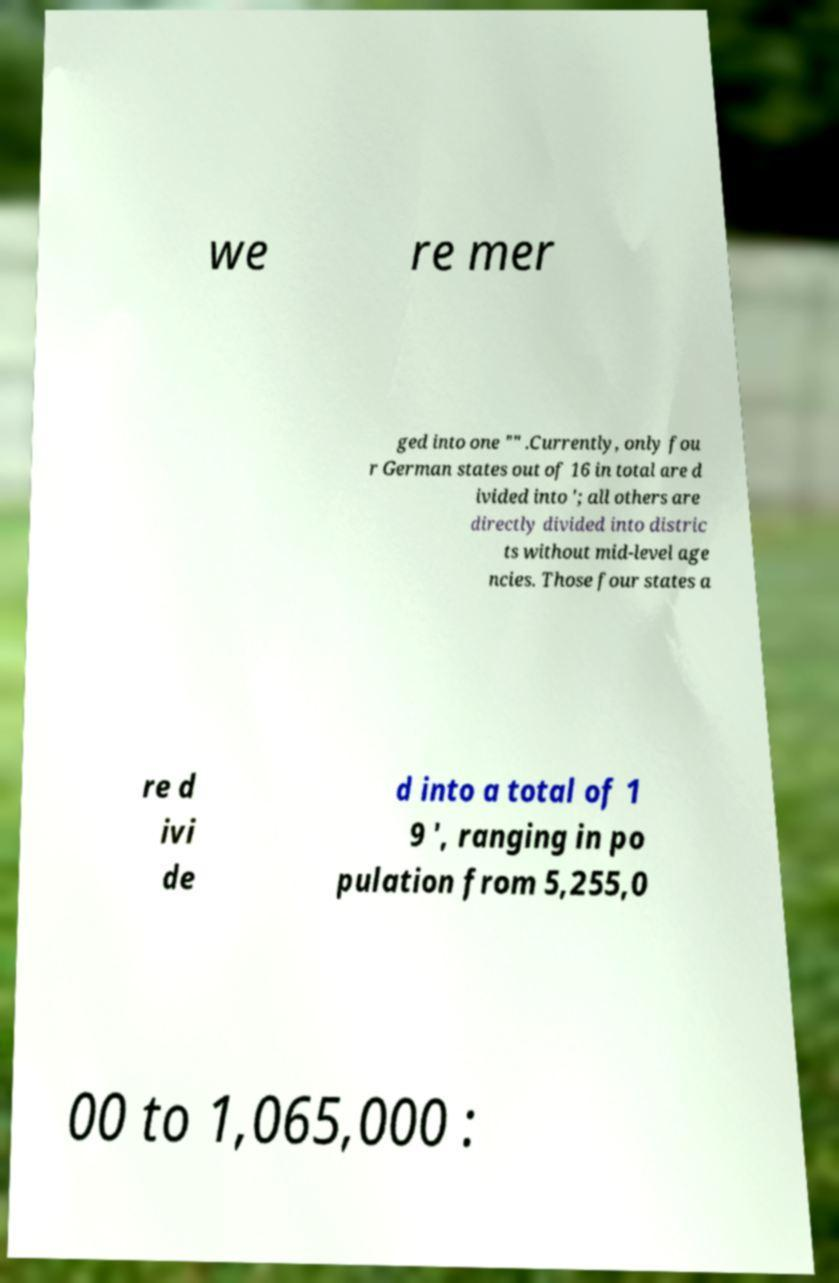Please read and relay the text visible in this image. What does it say? we re mer ged into one "" .Currently, only fou r German states out of 16 in total are d ivided into '; all others are directly divided into distric ts without mid-level age ncies. Those four states a re d ivi de d into a total of 1 9 ', ranging in po pulation from 5,255,0 00 to 1,065,000 : 